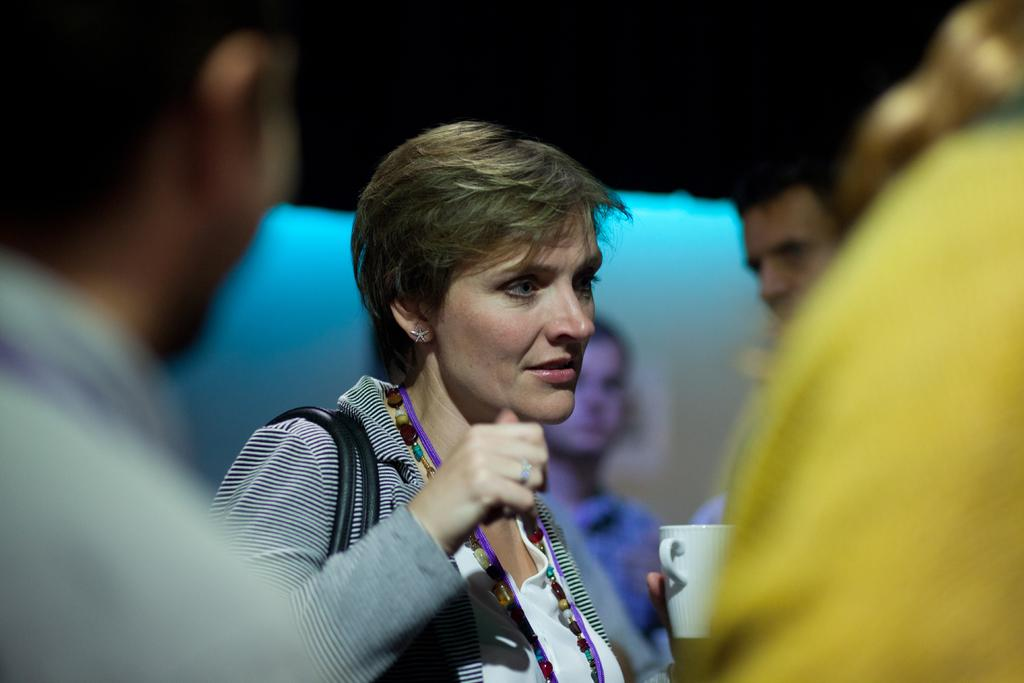What is happening in the image? There are people standing in the image. Can you describe what one of the people is holding? A woman is holding a coffee mug in the image. What can be observed about the background of the image? The background of the image is blurred. How many wings can be seen on the people in the image? There are no wings visible on the people in the image. What type of slave is depicted in the image? There is no depiction of a slave in the image; it features people standing and a woman holding a coffee mug. 